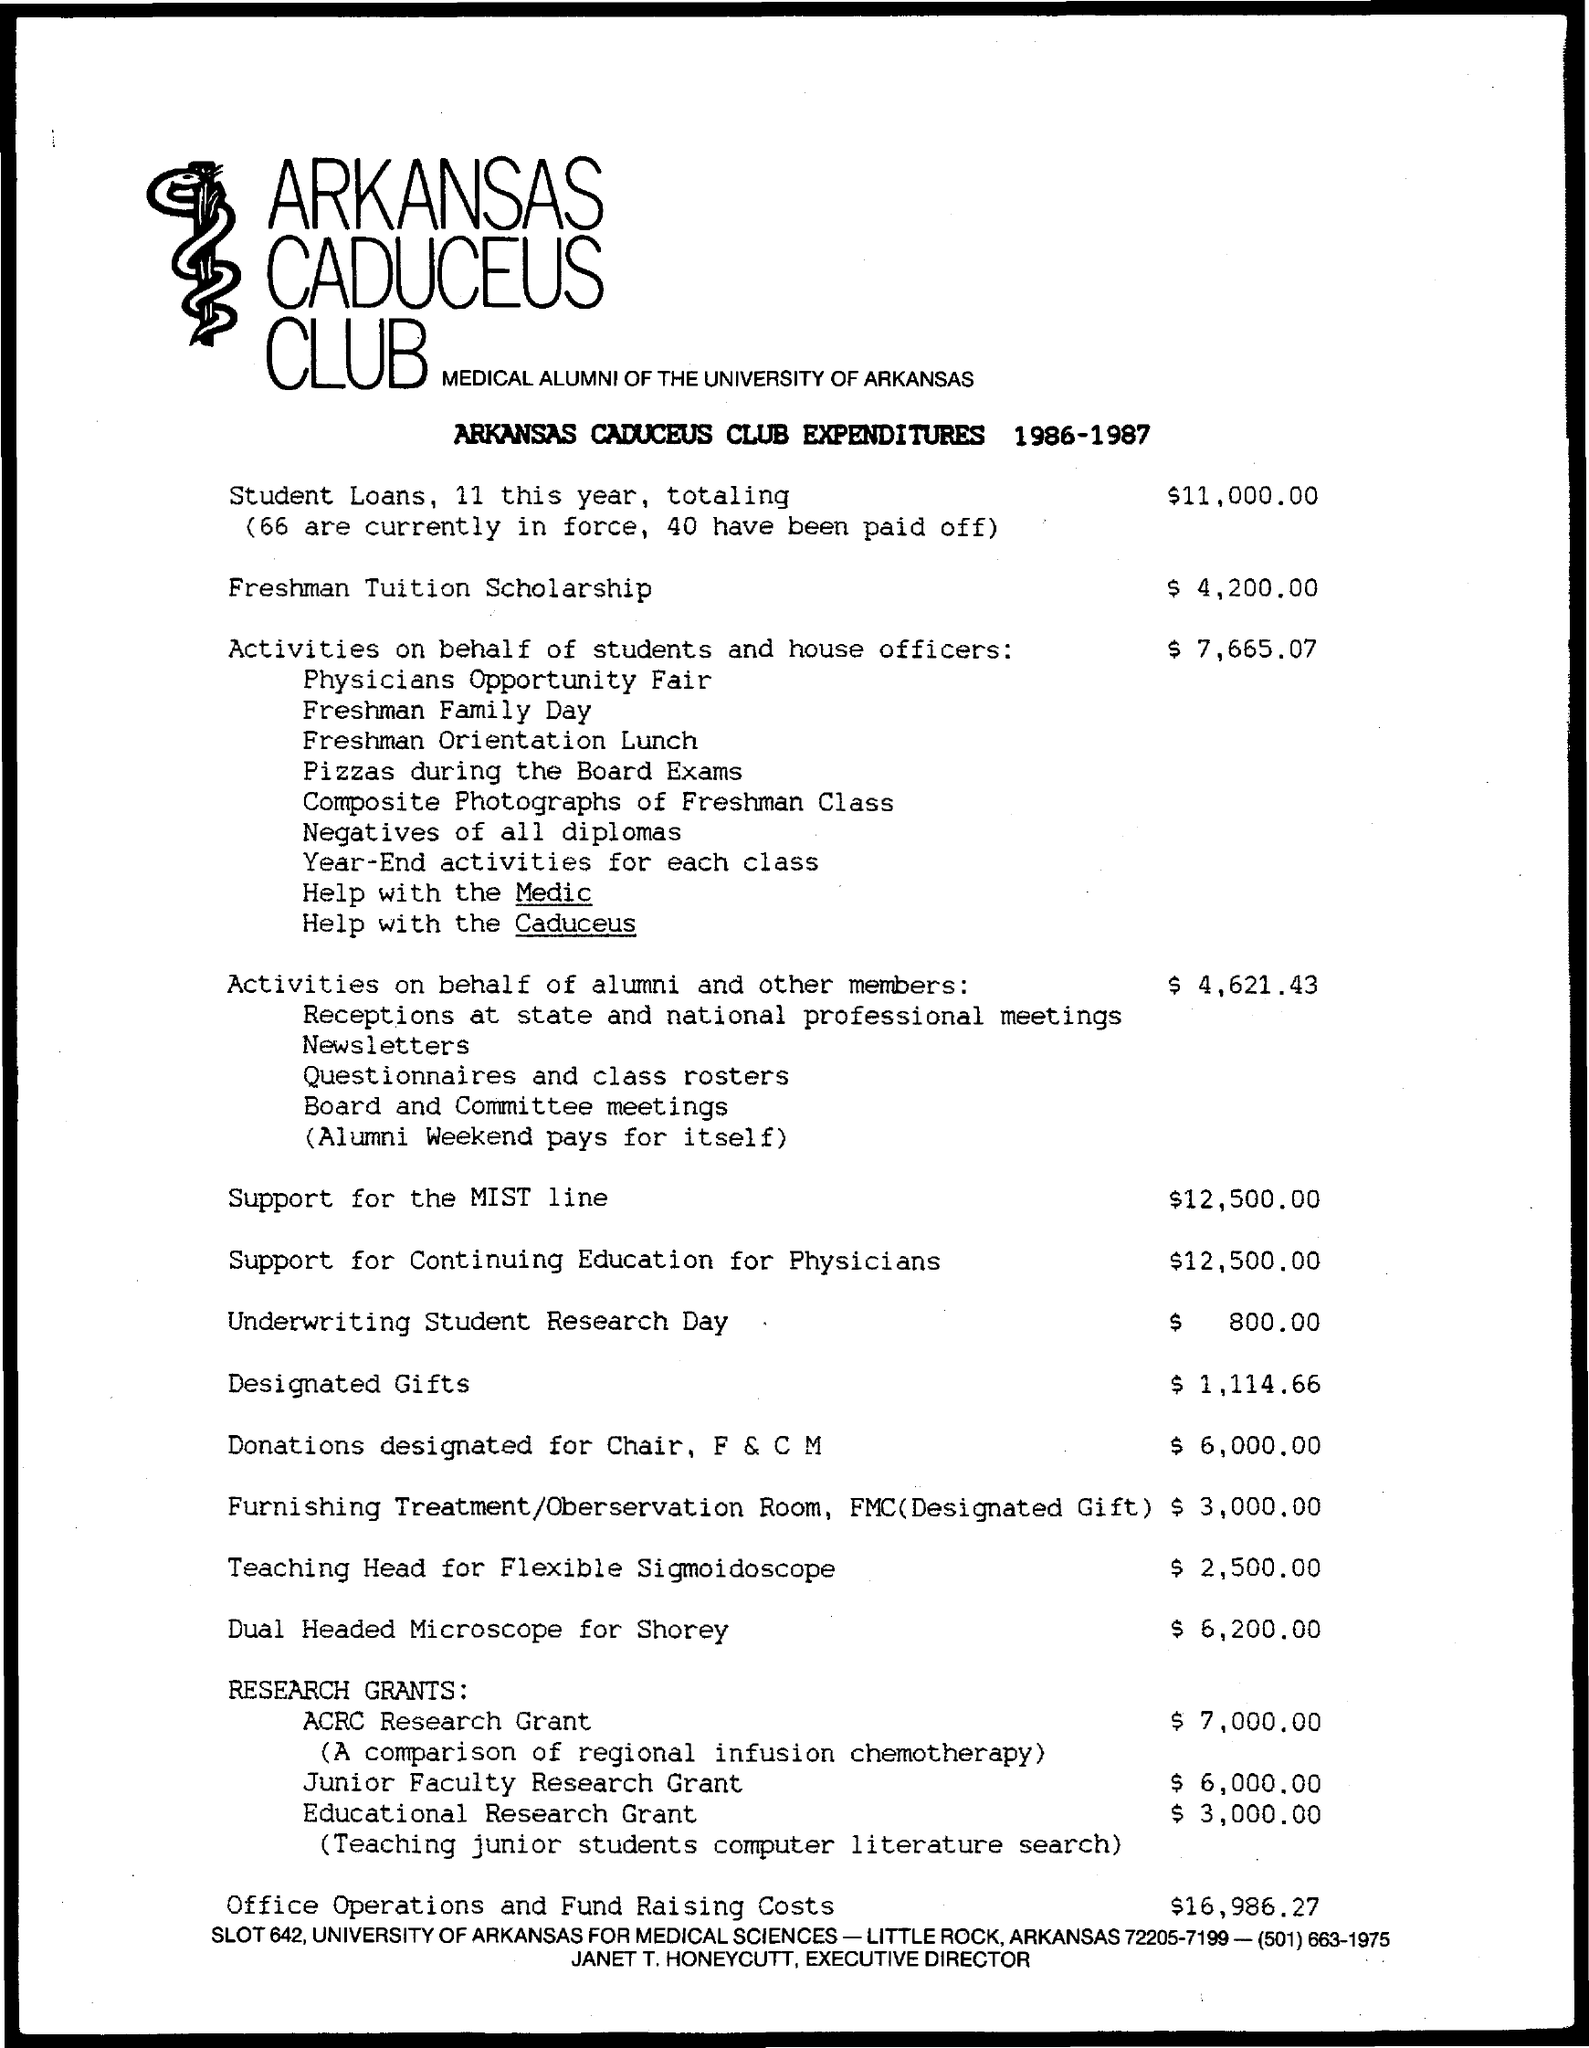What is the total expenditure towards  student loans this year?
Give a very brief answer. 11,000.00. What is the freshman tution scholarship?
Make the answer very short. $4,200.00. What is the amount for Activities on behalf of students and house officers?
Provide a succinct answer. 7,665.07. What is the amount for Activities on behalf of alumni and other members?
Offer a very short reply. $4,621.43. What is the support for MIST line?
Make the answer very short. 12,500.00. What is the support for continuing Education for Physicians?
Provide a short and direct response. $12,500.00. What is the amount for underwriting student research day?
Provide a short and direct response. $800.00. What is the amount for designated gifts?
Your answer should be very brief. $ 1,114.66. What is the amount for donation designated for Chair, P & C M?
Provide a short and direct response. $6,000.00. What is the amount FOR DUAL HEADED MICROSCOPE FOR SHOREY?
Your answer should be very brief. $6,200.00. 